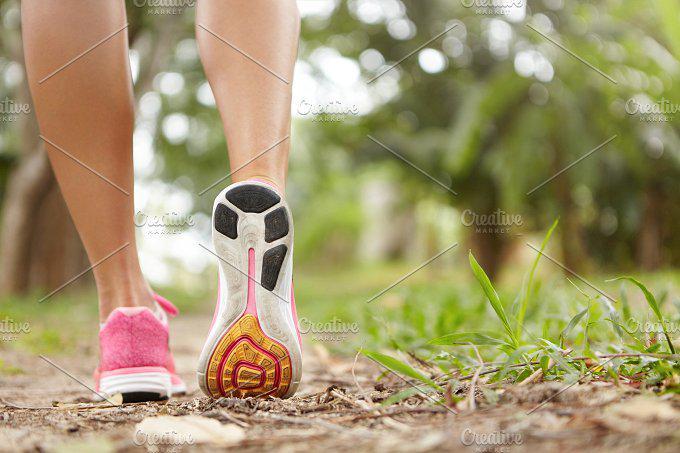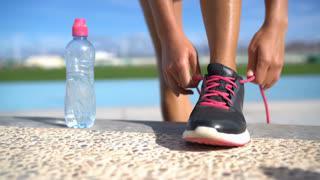The first image is the image on the left, the second image is the image on the right. Analyze the images presented: Is the assertion "There is a pair of empty shoes in the right image." valid? Answer yes or no. No. The first image is the image on the left, the second image is the image on the right. For the images displayed, is the sentence "One of the images shows a black shoe near a bottle of water." factually correct? Answer yes or no. Yes. 